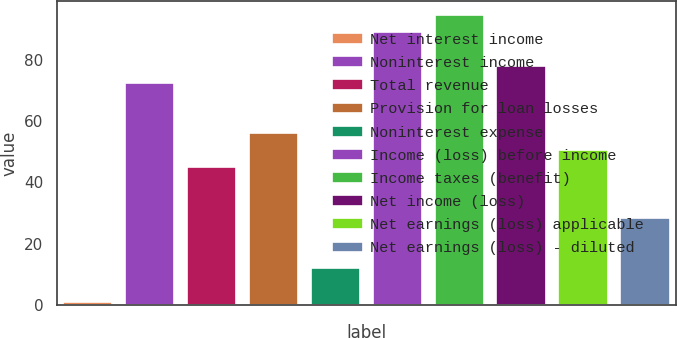<chart> <loc_0><loc_0><loc_500><loc_500><bar_chart><fcel>Net interest income<fcel>Noninterest income<fcel>Total revenue<fcel>Provision for loan losses<fcel>Noninterest expense<fcel>Income (loss) before income<fcel>Income taxes (benefit)<fcel>Net income (loss)<fcel>Net earnings (loss) applicable<fcel>Net earnings (loss) - diluted<nl><fcel>1<fcel>72.5<fcel>45<fcel>56<fcel>12<fcel>89<fcel>94.5<fcel>78<fcel>50.5<fcel>28.5<nl></chart> 